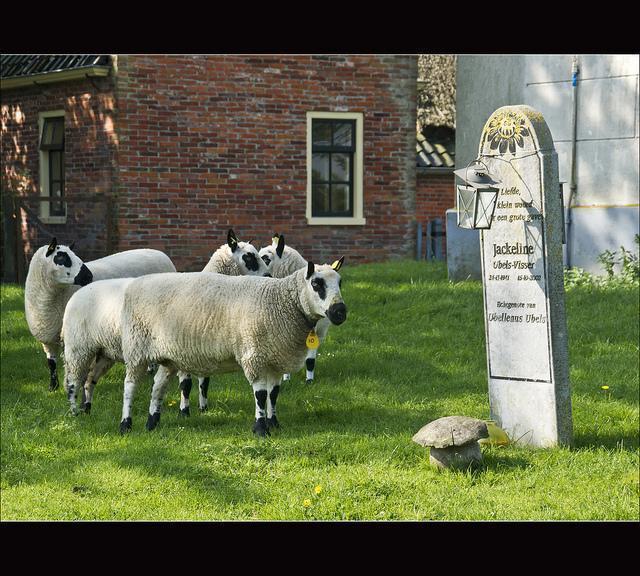What is around the animal in the foreground's neck?
From the following four choices, select the correct answer to address the question.
Options: Tag, medal, ribbon, scarf. Tag. What color are the patches around the eyes and noses of the sheep in this field?
Make your selection and explain in format: 'Answer: answer
Rationale: rationale.'
Options: Two, four, one, three. Answer: four.
Rationale: There are four patches. 